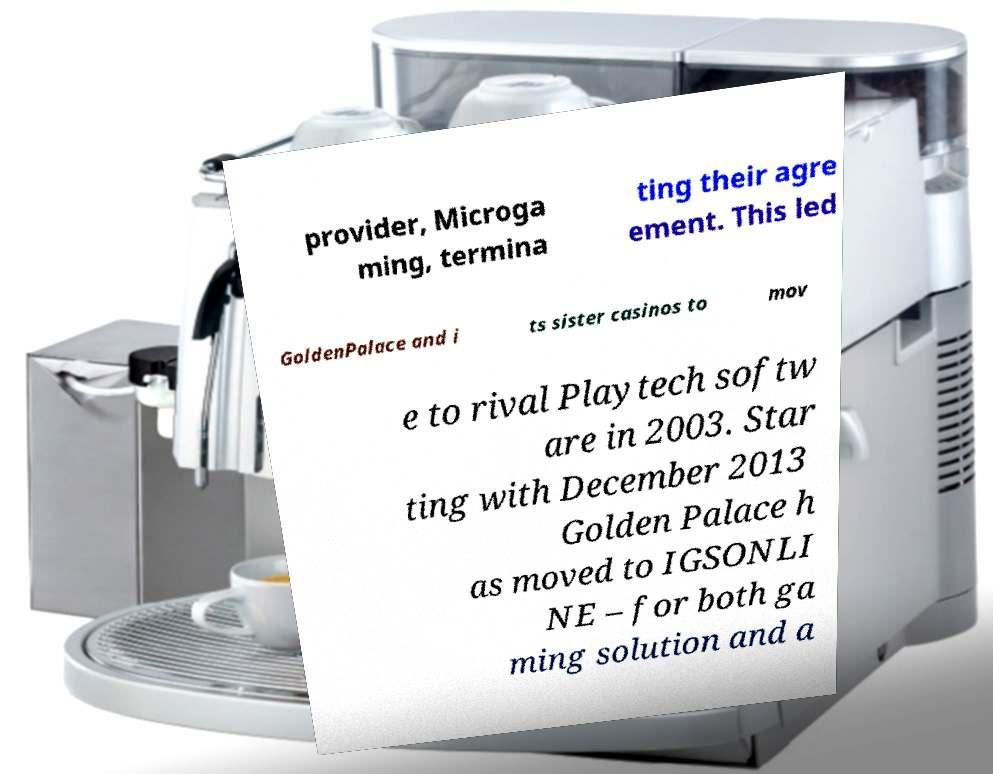What messages or text are displayed in this image? I need them in a readable, typed format. provider, Microga ming, termina ting their agre ement. This led GoldenPalace and i ts sister casinos to mov e to rival Playtech softw are in 2003. Star ting with December 2013 Golden Palace h as moved to IGSONLI NE – for both ga ming solution and a 